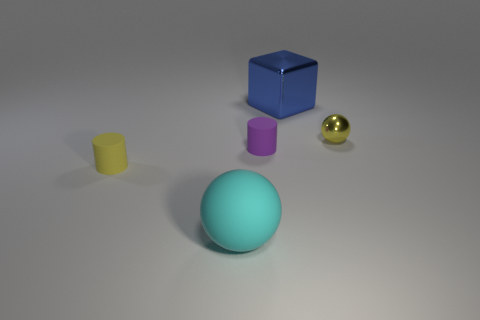Add 2 cylinders. How many objects exist? 7 Subtract all cylinders. How many objects are left? 3 Add 4 tiny gray metal blocks. How many tiny gray metal blocks exist? 4 Subtract 0 green balls. How many objects are left? 5 Subtract all blocks. Subtract all spheres. How many objects are left? 2 Add 5 blue cubes. How many blue cubes are left? 6 